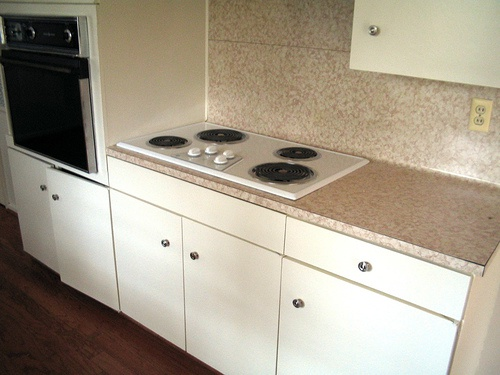Describe the objects in this image and their specific colors. I can see oven in gray, black, and darkgray tones and oven in gray, tan, black, and ivory tones in this image. 